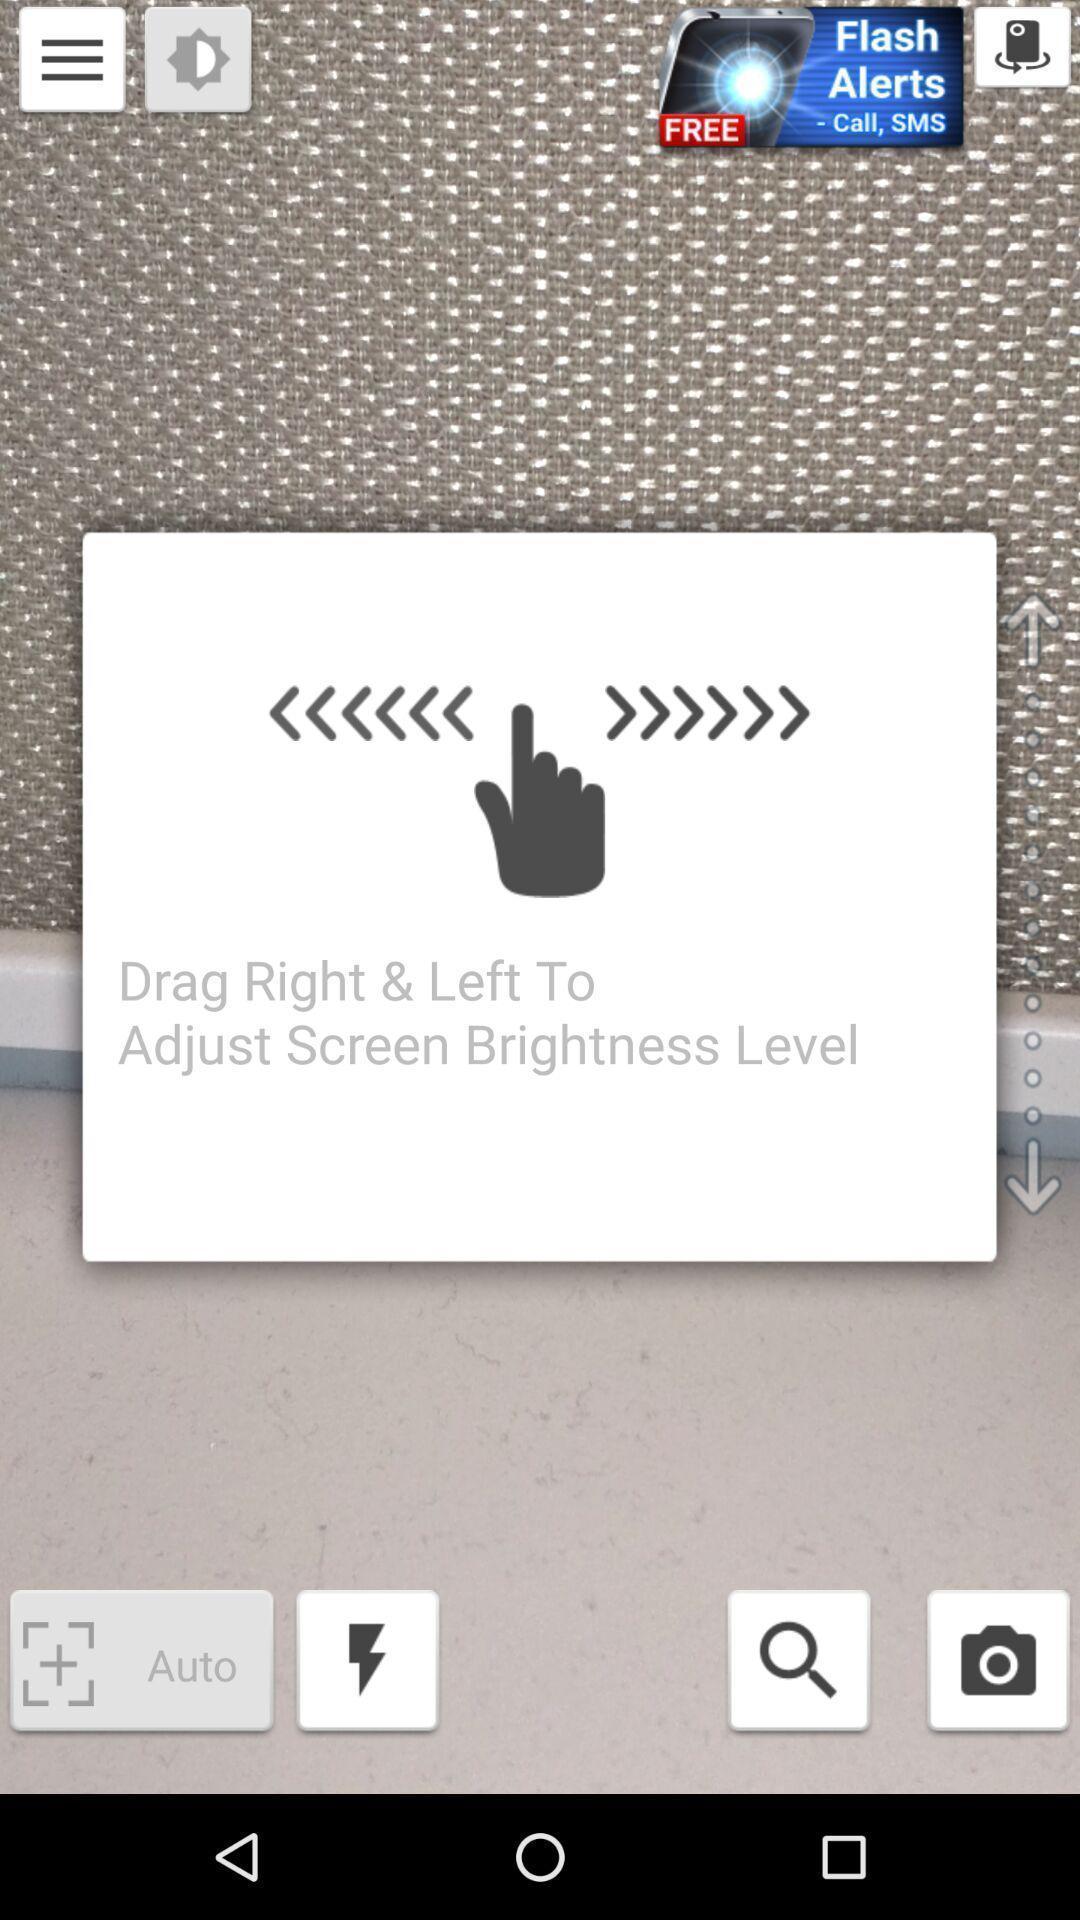Explain the elements present in this screenshot. Pop-up showing an instruction for brightness. 